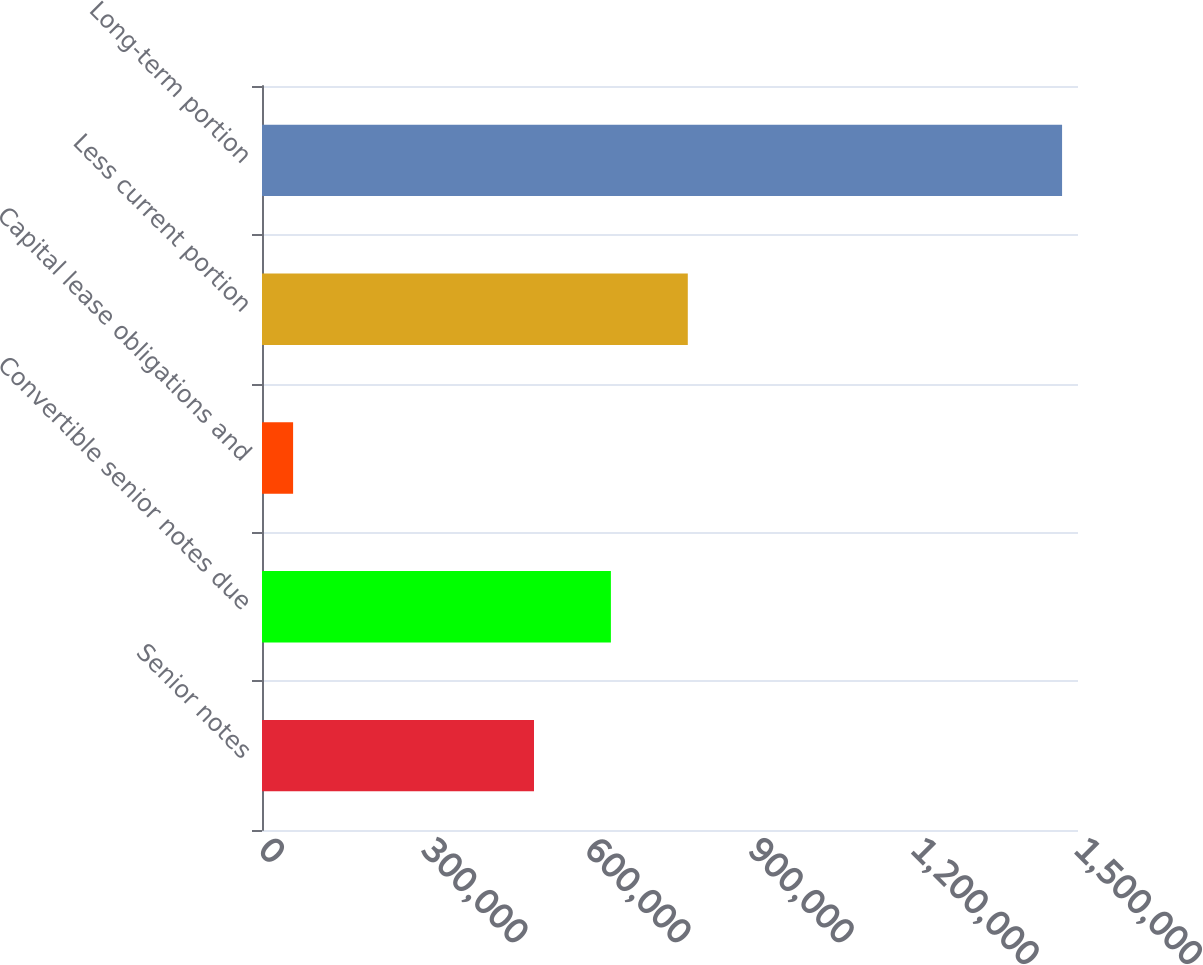Convert chart to OTSL. <chart><loc_0><loc_0><loc_500><loc_500><bar_chart><fcel>Senior notes<fcel>Convertible senior notes due<fcel>Capital lease obligations and<fcel>Less current portion<fcel>Long-term portion<nl><fcel>500000<fcel>641355<fcel>57175<fcel>782710<fcel>1.47073e+06<nl></chart> 